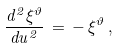Convert formula to latex. <formula><loc_0><loc_0><loc_500><loc_500>\frac { d ^ { 2 } \xi ^ { \vartheta } } { d u ^ { 2 } } \, = \, - \, \xi ^ { \vartheta } \, ,</formula> 